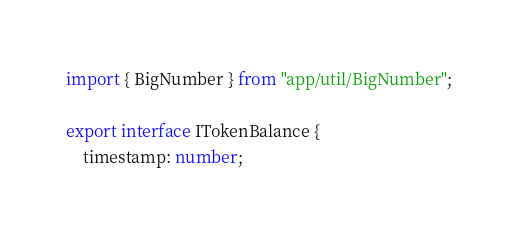<code> <loc_0><loc_0><loc_500><loc_500><_TypeScript_>import { BigNumber } from "app/util/BigNumber";

export interface ITokenBalance {
    timestamp: number;</code> 